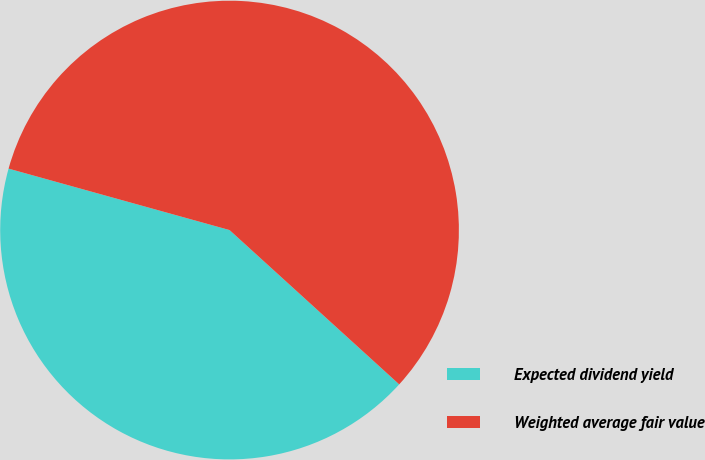<chart> <loc_0><loc_0><loc_500><loc_500><pie_chart><fcel>Expected dividend yield<fcel>Weighted average fair value<nl><fcel>42.57%<fcel>57.43%<nl></chart> 